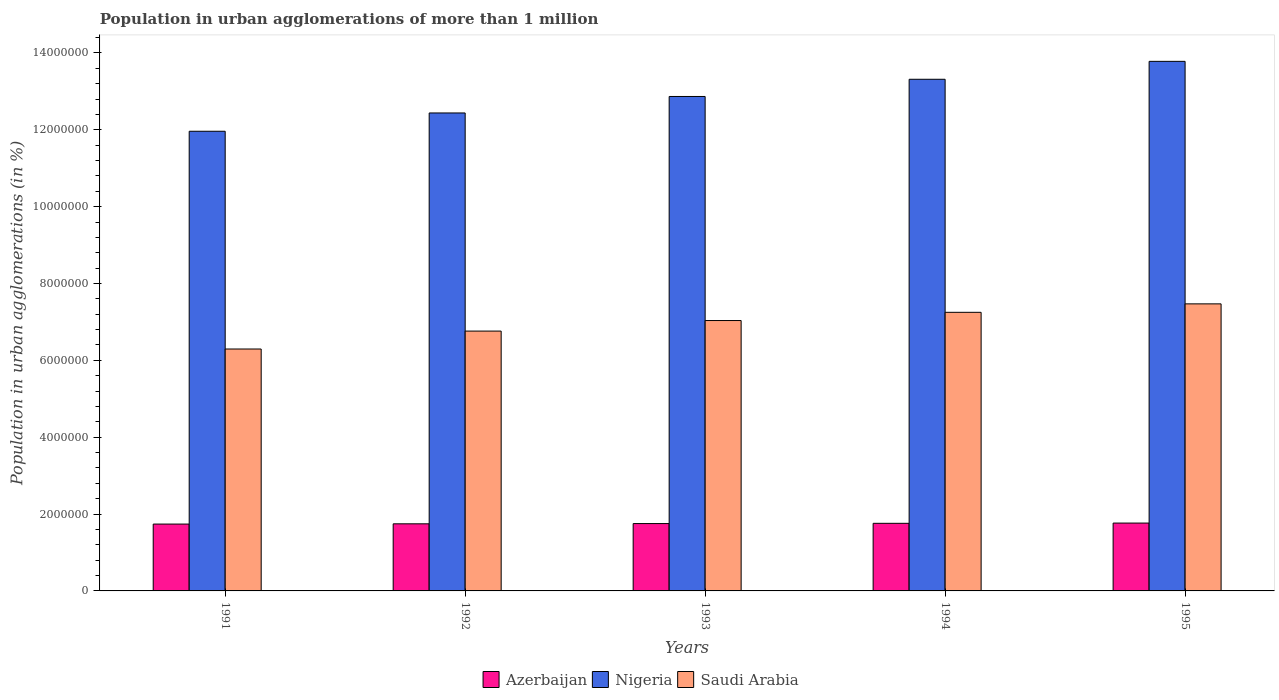How many different coloured bars are there?
Make the answer very short. 3. How many groups of bars are there?
Your answer should be compact. 5. Are the number of bars on each tick of the X-axis equal?
Your response must be concise. Yes. How many bars are there on the 4th tick from the left?
Provide a succinct answer. 3. What is the population in urban agglomerations in Azerbaijan in 1995?
Make the answer very short. 1.77e+06. Across all years, what is the maximum population in urban agglomerations in Azerbaijan?
Give a very brief answer. 1.77e+06. Across all years, what is the minimum population in urban agglomerations in Nigeria?
Provide a short and direct response. 1.20e+07. In which year was the population in urban agglomerations in Saudi Arabia maximum?
Keep it short and to the point. 1995. What is the total population in urban agglomerations in Azerbaijan in the graph?
Your answer should be compact. 8.76e+06. What is the difference between the population in urban agglomerations in Azerbaijan in 1991 and that in 1994?
Ensure brevity in your answer.  -1.93e+04. What is the difference between the population in urban agglomerations in Nigeria in 1993 and the population in urban agglomerations in Azerbaijan in 1991?
Offer a terse response. 1.11e+07. What is the average population in urban agglomerations in Azerbaijan per year?
Offer a terse response. 1.75e+06. In the year 1992, what is the difference between the population in urban agglomerations in Azerbaijan and population in urban agglomerations in Saudi Arabia?
Offer a very short reply. -5.02e+06. What is the ratio of the population in urban agglomerations in Azerbaijan in 1991 to that in 1995?
Provide a short and direct response. 0.99. What is the difference between the highest and the second highest population in urban agglomerations in Saudi Arabia?
Your response must be concise. 2.20e+05. What is the difference between the highest and the lowest population in urban agglomerations in Nigeria?
Your answer should be compact. 1.82e+06. What does the 3rd bar from the left in 1993 represents?
Keep it short and to the point. Saudi Arabia. What does the 1st bar from the right in 1993 represents?
Your answer should be very brief. Saudi Arabia. How many years are there in the graph?
Give a very brief answer. 5. Are the values on the major ticks of Y-axis written in scientific E-notation?
Your answer should be compact. No. Does the graph contain grids?
Provide a short and direct response. No. How are the legend labels stacked?
Keep it short and to the point. Horizontal. What is the title of the graph?
Keep it short and to the point. Population in urban agglomerations of more than 1 million. Does "Least developed countries" appear as one of the legend labels in the graph?
Provide a succinct answer. No. What is the label or title of the Y-axis?
Provide a short and direct response. Population in urban agglomerations (in %). What is the Population in urban agglomerations (in %) in Azerbaijan in 1991?
Provide a succinct answer. 1.74e+06. What is the Population in urban agglomerations (in %) of Nigeria in 1991?
Make the answer very short. 1.20e+07. What is the Population in urban agglomerations (in %) of Saudi Arabia in 1991?
Your answer should be very brief. 6.30e+06. What is the Population in urban agglomerations (in %) of Azerbaijan in 1992?
Offer a very short reply. 1.75e+06. What is the Population in urban agglomerations (in %) in Nigeria in 1992?
Your response must be concise. 1.24e+07. What is the Population in urban agglomerations (in %) of Saudi Arabia in 1992?
Provide a succinct answer. 6.76e+06. What is the Population in urban agglomerations (in %) of Azerbaijan in 1993?
Your answer should be very brief. 1.75e+06. What is the Population in urban agglomerations (in %) of Nigeria in 1993?
Offer a terse response. 1.29e+07. What is the Population in urban agglomerations (in %) of Saudi Arabia in 1993?
Provide a short and direct response. 7.04e+06. What is the Population in urban agglomerations (in %) of Azerbaijan in 1994?
Your response must be concise. 1.76e+06. What is the Population in urban agglomerations (in %) of Nigeria in 1994?
Give a very brief answer. 1.33e+07. What is the Population in urban agglomerations (in %) of Saudi Arabia in 1994?
Offer a very short reply. 7.25e+06. What is the Population in urban agglomerations (in %) in Azerbaijan in 1995?
Keep it short and to the point. 1.77e+06. What is the Population in urban agglomerations (in %) of Nigeria in 1995?
Give a very brief answer. 1.38e+07. What is the Population in urban agglomerations (in %) in Saudi Arabia in 1995?
Keep it short and to the point. 7.47e+06. Across all years, what is the maximum Population in urban agglomerations (in %) in Azerbaijan?
Your response must be concise. 1.77e+06. Across all years, what is the maximum Population in urban agglomerations (in %) in Nigeria?
Keep it short and to the point. 1.38e+07. Across all years, what is the maximum Population in urban agglomerations (in %) in Saudi Arabia?
Offer a terse response. 7.47e+06. Across all years, what is the minimum Population in urban agglomerations (in %) in Azerbaijan?
Offer a very short reply. 1.74e+06. Across all years, what is the minimum Population in urban agglomerations (in %) of Nigeria?
Your answer should be very brief. 1.20e+07. Across all years, what is the minimum Population in urban agglomerations (in %) of Saudi Arabia?
Provide a short and direct response. 6.30e+06. What is the total Population in urban agglomerations (in %) in Azerbaijan in the graph?
Give a very brief answer. 8.76e+06. What is the total Population in urban agglomerations (in %) in Nigeria in the graph?
Offer a very short reply. 6.44e+07. What is the total Population in urban agglomerations (in %) of Saudi Arabia in the graph?
Provide a short and direct response. 3.48e+07. What is the difference between the Population in urban agglomerations (in %) of Azerbaijan in 1991 and that in 1992?
Your answer should be compact. -6403. What is the difference between the Population in urban agglomerations (in %) in Nigeria in 1991 and that in 1992?
Your response must be concise. -4.76e+05. What is the difference between the Population in urban agglomerations (in %) in Saudi Arabia in 1991 and that in 1992?
Give a very brief answer. -4.66e+05. What is the difference between the Population in urban agglomerations (in %) in Azerbaijan in 1991 and that in 1993?
Ensure brevity in your answer.  -1.28e+04. What is the difference between the Population in urban agglomerations (in %) of Nigeria in 1991 and that in 1993?
Offer a terse response. -9.05e+05. What is the difference between the Population in urban agglomerations (in %) in Saudi Arabia in 1991 and that in 1993?
Provide a short and direct response. -7.41e+05. What is the difference between the Population in urban agglomerations (in %) in Azerbaijan in 1991 and that in 1994?
Make the answer very short. -1.93e+04. What is the difference between the Population in urban agglomerations (in %) of Nigeria in 1991 and that in 1994?
Offer a very short reply. -1.35e+06. What is the difference between the Population in urban agglomerations (in %) in Saudi Arabia in 1991 and that in 1994?
Give a very brief answer. -9.55e+05. What is the difference between the Population in urban agglomerations (in %) of Azerbaijan in 1991 and that in 1995?
Offer a very short reply. -2.57e+04. What is the difference between the Population in urban agglomerations (in %) in Nigeria in 1991 and that in 1995?
Your answer should be very brief. -1.82e+06. What is the difference between the Population in urban agglomerations (in %) of Saudi Arabia in 1991 and that in 1995?
Provide a succinct answer. -1.17e+06. What is the difference between the Population in urban agglomerations (in %) in Azerbaijan in 1992 and that in 1993?
Provide a short and direct response. -6410. What is the difference between the Population in urban agglomerations (in %) of Nigeria in 1992 and that in 1993?
Provide a succinct answer. -4.29e+05. What is the difference between the Population in urban agglomerations (in %) of Saudi Arabia in 1992 and that in 1993?
Your answer should be very brief. -2.75e+05. What is the difference between the Population in urban agglomerations (in %) in Azerbaijan in 1992 and that in 1994?
Keep it short and to the point. -1.29e+04. What is the difference between the Population in urban agglomerations (in %) in Nigeria in 1992 and that in 1994?
Your answer should be compact. -8.77e+05. What is the difference between the Population in urban agglomerations (in %) of Saudi Arabia in 1992 and that in 1994?
Offer a terse response. -4.88e+05. What is the difference between the Population in urban agglomerations (in %) in Azerbaijan in 1992 and that in 1995?
Offer a terse response. -1.93e+04. What is the difference between the Population in urban agglomerations (in %) of Nigeria in 1992 and that in 1995?
Give a very brief answer. -1.34e+06. What is the difference between the Population in urban agglomerations (in %) of Saudi Arabia in 1992 and that in 1995?
Provide a short and direct response. -7.08e+05. What is the difference between the Population in urban agglomerations (in %) of Azerbaijan in 1993 and that in 1994?
Keep it short and to the point. -6441. What is the difference between the Population in urban agglomerations (in %) of Nigeria in 1993 and that in 1994?
Your response must be concise. -4.48e+05. What is the difference between the Population in urban agglomerations (in %) in Saudi Arabia in 1993 and that in 1994?
Offer a very short reply. -2.14e+05. What is the difference between the Population in urban agglomerations (in %) in Azerbaijan in 1993 and that in 1995?
Keep it short and to the point. -1.29e+04. What is the difference between the Population in urban agglomerations (in %) in Nigeria in 1993 and that in 1995?
Provide a short and direct response. -9.14e+05. What is the difference between the Population in urban agglomerations (in %) of Saudi Arabia in 1993 and that in 1995?
Ensure brevity in your answer.  -4.34e+05. What is the difference between the Population in urban agglomerations (in %) of Azerbaijan in 1994 and that in 1995?
Your response must be concise. -6466. What is the difference between the Population in urban agglomerations (in %) of Nigeria in 1994 and that in 1995?
Your answer should be compact. -4.66e+05. What is the difference between the Population in urban agglomerations (in %) in Saudi Arabia in 1994 and that in 1995?
Provide a short and direct response. -2.20e+05. What is the difference between the Population in urban agglomerations (in %) in Azerbaijan in 1991 and the Population in urban agglomerations (in %) in Nigeria in 1992?
Offer a terse response. -1.07e+07. What is the difference between the Population in urban agglomerations (in %) in Azerbaijan in 1991 and the Population in urban agglomerations (in %) in Saudi Arabia in 1992?
Offer a very short reply. -5.02e+06. What is the difference between the Population in urban agglomerations (in %) of Nigeria in 1991 and the Population in urban agglomerations (in %) of Saudi Arabia in 1992?
Give a very brief answer. 5.20e+06. What is the difference between the Population in urban agglomerations (in %) in Azerbaijan in 1991 and the Population in urban agglomerations (in %) in Nigeria in 1993?
Provide a succinct answer. -1.11e+07. What is the difference between the Population in urban agglomerations (in %) in Azerbaijan in 1991 and the Population in urban agglomerations (in %) in Saudi Arabia in 1993?
Keep it short and to the point. -5.30e+06. What is the difference between the Population in urban agglomerations (in %) in Nigeria in 1991 and the Population in urban agglomerations (in %) in Saudi Arabia in 1993?
Provide a succinct answer. 4.93e+06. What is the difference between the Population in urban agglomerations (in %) in Azerbaijan in 1991 and the Population in urban agglomerations (in %) in Nigeria in 1994?
Ensure brevity in your answer.  -1.16e+07. What is the difference between the Population in urban agglomerations (in %) of Azerbaijan in 1991 and the Population in urban agglomerations (in %) of Saudi Arabia in 1994?
Your response must be concise. -5.51e+06. What is the difference between the Population in urban agglomerations (in %) in Nigeria in 1991 and the Population in urban agglomerations (in %) in Saudi Arabia in 1994?
Ensure brevity in your answer.  4.71e+06. What is the difference between the Population in urban agglomerations (in %) in Azerbaijan in 1991 and the Population in urban agglomerations (in %) in Nigeria in 1995?
Offer a very short reply. -1.20e+07. What is the difference between the Population in urban agglomerations (in %) of Azerbaijan in 1991 and the Population in urban agglomerations (in %) of Saudi Arabia in 1995?
Offer a very short reply. -5.73e+06. What is the difference between the Population in urban agglomerations (in %) of Nigeria in 1991 and the Population in urban agglomerations (in %) of Saudi Arabia in 1995?
Keep it short and to the point. 4.49e+06. What is the difference between the Population in urban agglomerations (in %) of Azerbaijan in 1992 and the Population in urban agglomerations (in %) of Nigeria in 1993?
Your answer should be very brief. -1.11e+07. What is the difference between the Population in urban agglomerations (in %) in Azerbaijan in 1992 and the Population in urban agglomerations (in %) in Saudi Arabia in 1993?
Provide a short and direct response. -5.29e+06. What is the difference between the Population in urban agglomerations (in %) in Nigeria in 1992 and the Population in urban agglomerations (in %) in Saudi Arabia in 1993?
Provide a succinct answer. 5.40e+06. What is the difference between the Population in urban agglomerations (in %) in Azerbaijan in 1992 and the Population in urban agglomerations (in %) in Nigeria in 1994?
Provide a short and direct response. -1.16e+07. What is the difference between the Population in urban agglomerations (in %) of Azerbaijan in 1992 and the Population in urban agglomerations (in %) of Saudi Arabia in 1994?
Make the answer very short. -5.50e+06. What is the difference between the Population in urban agglomerations (in %) of Nigeria in 1992 and the Population in urban agglomerations (in %) of Saudi Arabia in 1994?
Your response must be concise. 5.19e+06. What is the difference between the Population in urban agglomerations (in %) in Azerbaijan in 1992 and the Population in urban agglomerations (in %) in Nigeria in 1995?
Offer a terse response. -1.20e+07. What is the difference between the Population in urban agglomerations (in %) of Azerbaijan in 1992 and the Population in urban agglomerations (in %) of Saudi Arabia in 1995?
Keep it short and to the point. -5.72e+06. What is the difference between the Population in urban agglomerations (in %) of Nigeria in 1992 and the Population in urban agglomerations (in %) of Saudi Arabia in 1995?
Your answer should be compact. 4.97e+06. What is the difference between the Population in urban agglomerations (in %) of Azerbaijan in 1993 and the Population in urban agglomerations (in %) of Nigeria in 1994?
Ensure brevity in your answer.  -1.16e+07. What is the difference between the Population in urban agglomerations (in %) in Azerbaijan in 1993 and the Population in urban agglomerations (in %) in Saudi Arabia in 1994?
Your answer should be very brief. -5.50e+06. What is the difference between the Population in urban agglomerations (in %) in Nigeria in 1993 and the Population in urban agglomerations (in %) in Saudi Arabia in 1994?
Your response must be concise. 5.62e+06. What is the difference between the Population in urban agglomerations (in %) in Azerbaijan in 1993 and the Population in urban agglomerations (in %) in Nigeria in 1995?
Offer a terse response. -1.20e+07. What is the difference between the Population in urban agglomerations (in %) of Azerbaijan in 1993 and the Population in urban agglomerations (in %) of Saudi Arabia in 1995?
Ensure brevity in your answer.  -5.72e+06. What is the difference between the Population in urban agglomerations (in %) of Nigeria in 1993 and the Population in urban agglomerations (in %) of Saudi Arabia in 1995?
Make the answer very short. 5.40e+06. What is the difference between the Population in urban agglomerations (in %) of Azerbaijan in 1994 and the Population in urban agglomerations (in %) of Nigeria in 1995?
Your response must be concise. -1.20e+07. What is the difference between the Population in urban agglomerations (in %) in Azerbaijan in 1994 and the Population in urban agglomerations (in %) in Saudi Arabia in 1995?
Your answer should be very brief. -5.71e+06. What is the difference between the Population in urban agglomerations (in %) of Nigeria in 1994 and the Population in urban agglomerations (in %) of Saudi Arabia in 1995?
Your response must be concise. 5.84e+06. What is the average Population in urban agglomerations (in %) in Azerbaijan per year?
Ensure brevity in your answer.  1.75e+06. What is the average Population in urban agglomerations (in %) of Nigeria per year?
Provide a short and direct response. 1.29e+07. What is the average Population in urban agglomerations (in %) of Saudi Arabia per year?
Provide a succinct answer. 6.96e+06. In the year 1991, what is the difference between the Population in urban agglomerations (in %) of Azerbaijan and Population in urban agglomerations (in %) of Nigeria?
Offer a terse response. -1.02e+07. In the year 1991, what is the difference between the Population in urban agglomerations (in %) of Azerbaijan and Population in urban agglomerations (in %) of Saudi Arabia?
Ensure brevity in your answer.  -4.56e+06. In the year 1991, what is the difference between the Population in urban agglomerations (in %) of Nigeria and Population in urban agglomerations (in %) of Saudi Arabia?
Offer a very short reply. 5.67e+06. In the year 1992, what is the difference between the Population in urban agglomerations (in %) of Azerbaijan and Population in urban agglomerations (in %) of Nigeria?
Provide a succinct answer. -1.07e+07. In the year 1992, what is the difference between the Population in urban agglomerations (in %) in Azerbaijan and Population in urban agglomerations (in %) in Saudi Arabia?
Provide a succinct answer. -5.02e+06. In the year 1992, what is the difference between the Population in urban agglomerations (in %) of Nigeria and Population in urban agglomerations (in %) of Saudi Arabia?
Keep it short and to the point. 5.68e+06. In the year 1993, what is the difference between the Population in urban agglomerations (in %) in Azerbaijan and Population in urban agglomerations (in %) in Nigeria?
Offer a terse response. -1.11e+07. In the year 1993, what is the difference between the Population in urban agglomerations (in %) of Azerbaijan and Population in urban agglomerations (in %) of Saudi Arabia?
Your response must be concise. -5.28e+06. In the year 1993, what is the difference between the Population in urban agglomerations (in %) in Nigeria and Population in urban agglomerations (in %) in Saudi Arabia?
Your answer should be compact. 5.83e+06. In the year 1994, what is the difference between the Population in urban agglomerations (in %) in Azerbaijan and Population in urban agglomerations (in %) in Nigeria?
Provide a short and direct response. -1.16e+07. In the year 1994, what is the difference between the Population in urban agglomerations (in %) in Azerbaijan and Population in urban agglomerations (in %) in Saudi Arabia?
Give a very brief answer. -5.49e+06. In the year 1994, what is the difference between the Population in urban agglomerations (in %) of Nigeria and Population in urban agglomerations (in %) of Saudi Arabia?
Ensure brevity in your answer.  6.06e+06. In the year 1995, what is the difference between the Population in urban agglomerations (in %) in Azerbaijan and Population in urban agglomerations (in %) in Nigeria?
Your answer should be very brief. -1.20e+07. In the year 1995, what is the difference between the Population in urban agglomerations (in %) in Azerbaijan and Population in urban agglomerations (in %) in Saudi Arabia?
Your answer should be very brief. -5.70e+06. In the year 1995, what is the difference between the Population in urban agglomerations (in %) of Nigeria and Population in urban agglomerations (in %) of Saudi Arabia?
Provide a succinct answer. 6.31e+06. What is the ratio of the Population in urban agglomerations (in %) of Azerbaijan in 1991 to that in 1992?
Keep it short and to the point. 1. What is the ratio of the Population in urban agglomerations (in %) in Nigeria in 1991 to that in 1992?
Provide a short and direct response. 0.96. What is the ratio of the Population in urban agglomerations (in %) of Azerbaijan in 1991 to that in 1993?
Provide a short and direct response. 0.99. What is the ratio of the Population in urban agglomerations (in %) of Nigeria in 1991 to that in 1993?
Your answer should be compact. 0.93. What is the ratio of the Population in urban agglomerations (in %) in Saudi Arabia in 1991 to that in 1993?
Your answer should be very brief. 0.89. What is the ratio of the Population in urban agglomerations (in %) in Nigeria in 1991 to that in 1994?
Ensure brevity in your answer.  0.9. What is the ratio of the Population in urban agglomerations (in %) of Saudi Arabia in 1991 to that in 1994?
Make the answer very short. 0.87. What is the ratio of the Population in urban agglomerations (in %) of Azerbaijan in 1991 to that in 1995?
Your response must be concise. 0.99. What is the ratio of the Population in urban agglomerations (in %) in Nigeria in 1991 to that in 1995?
Your answer should be very brief. 0.87. What is the ratio of the Population in urban agglomerations (in %) of Saudi Arabia in 1991 to that in 1995?
Ensure brevity in your answer.  0.84. What is the ratio of the Population in urban agglomerations (in %) of Azerbaijan in 1992 to that in 1993?
Make the answer very short. 1. What is the ratio of the Population in urban agglomerations (in %) in Nigeria in 1992 to that in 1993?
Make the answer very short. 0.97. What is the ratio of the Population in urban agglomerations (in %) in Saudi Arabia in 1992 to that in 1993?
Provide a succinct answer. 0.96. What is the ratio of the Population in urban agglomerations (in %) of Nigeria in 1992 to that in 1994?
Your answer should be very brief. 0.93. What is the ratio of the Population in urban agglomerations (in %) of Saudi Arabia in 1992 to that in 1994?
Make the answer very short. 0.93. What is the ratio of the Population in urban agglomerations (in %) of Nigeria in 1992 to that in 1995?
Provide a short and direct response. 0.9. What is the ratio of the Population in urban agglomerations (in %) in Saudi Arabia in 1992 to that in 1995?
Offer a very short reply. 0.91. What is the ratio of the Population in urban agglomerations (in %) of Nigeria in 1993 to that in 1994?
Make the answer very short. 0.97. What is the ratio of the Population in urban agglomerations (in %) of Saudi Arabia in 1993 to that in 1994?
Offer a very short reply. 0.97. What is the ratio of the Population in urban agglomerations (in %) of Nigeria in 1993 to that in 1995?
Offer a very short reply. 0.93. What is the ratio of the Population in urban agglomerations (in %) in Saudi Arabia in 1993 to that in 1995?
Offer a terse response. 0.94. What is the ratio of the Population in urban agglomerations (in %) of Nigeria in 1994 to that in 1995?
Your answer should be very brief. 0.97. What is the ratio of the Population in urban agglomerations (in %) in Saudi Arabia in 1994 to that in 1995?
Provide a short and direct response. 0.97. What is the difference between the highest and the second highest Population in urban agglomerations (in %) in Azerbaijan?
Your response must be concise. 6466. What is the difference between the highest and the second highest Population in urban agglomerations (in %) in Nigeria?
Your answer should be compact. 4.66e+05. What is the difference between the highest and the second highest Population in urban agglomerations (in %) of Saudi Arabia?
Offer a very short reply. 2.20e+05. What is the difference between the highest and the lowest Population in urban agglomerations (in %) of Azerbaijan?
Offer a very short reply. 2.57e+04. What is the difference between the highest and the lowest Population in urban agglomerations (in %) of Nigeria?
Provide a short and direct response. 1.82e+06. What is the difference between the highest and the lowest Population in urban agglomerations (in %) in Saudi Arabia?
Make the answer very short. 1.17e+06. 